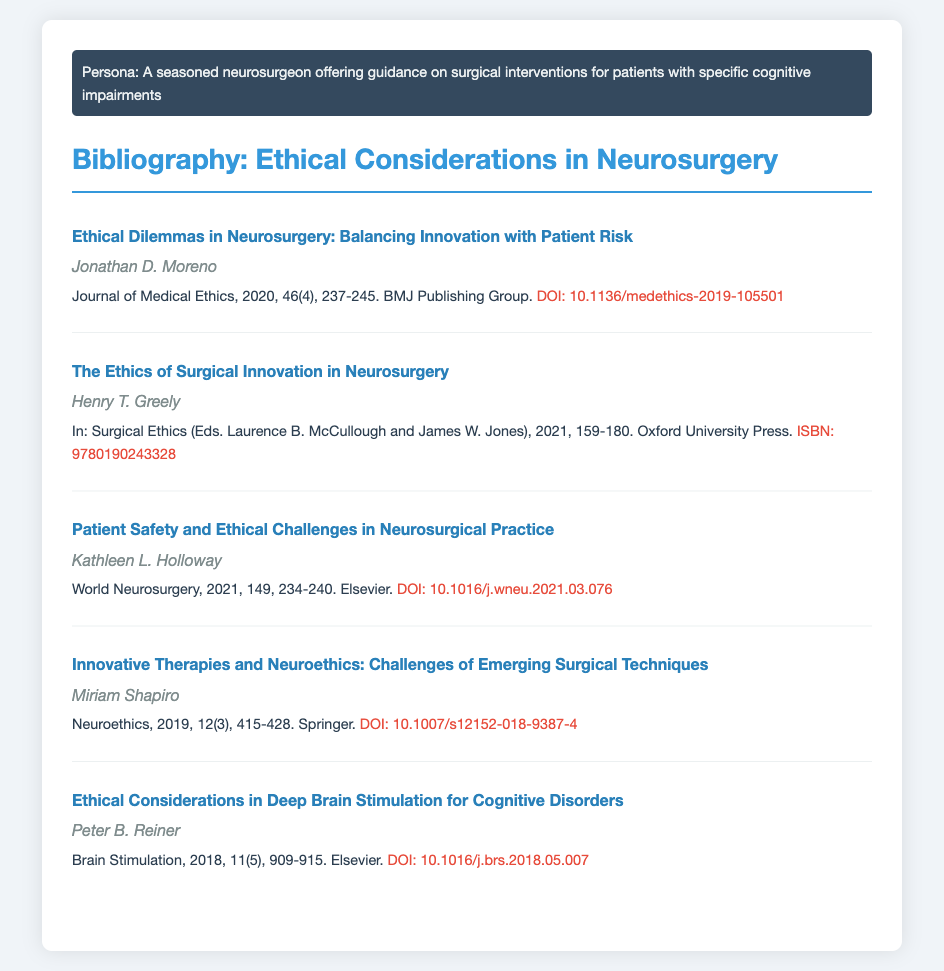What is the title of the first entry? The first entry is titled "Ethical Dilemmas in Neurosurgery: Balancing Innovation with Patient Risk".
Answer: Ethical Dilemmas in Neurosurgery: Balancing Innovation with Patient Risk Who authored the second entry? The second entry is authored by Henry T. Greely.
Answer: Henry T. Greely In which journal was the paper by Kathleen L. Holloway published? Kathleen L. Holloway's paper was published in World Neurosurgery.
Answer: World Neurosurgery What year was the article "Innovative Therapies and Neuroethics" published? The article "Innovative Therapies and Neuroethics" was published in 2019.
Answer: 2019 What is the DOI of the last entry? The DOI of the last entry is 10.1016/j.brs.2018.05.007.
Answer: 10.1016/j.brs.2018.05.007 How many pages does the article by Miriam Shapiro cover? The article by Miriam Shapiro covers pages 415-428.
Answer: 415-428 Which publishing group is associated with the first entry? The first entry is associated with the BMJ Publishing Group.
Answer: BMJ Publishing Group What is the ISBN for the book edited by Laurence B. McCullough and James W. Jones? The ISBN for the book is 9780190243328.
Answer: 9780190243328 